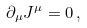<formula> <loc_0><loc_0><loc_500><loc_500>\partial _ { \mu } J ^ { \mu } = 0 \, ,</formula> 